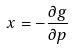Convert formula to latex. <formula><loc_0><loc_0><loc_500><loc_500>x = - \frac { \partial g } { \partial p }</formula> 